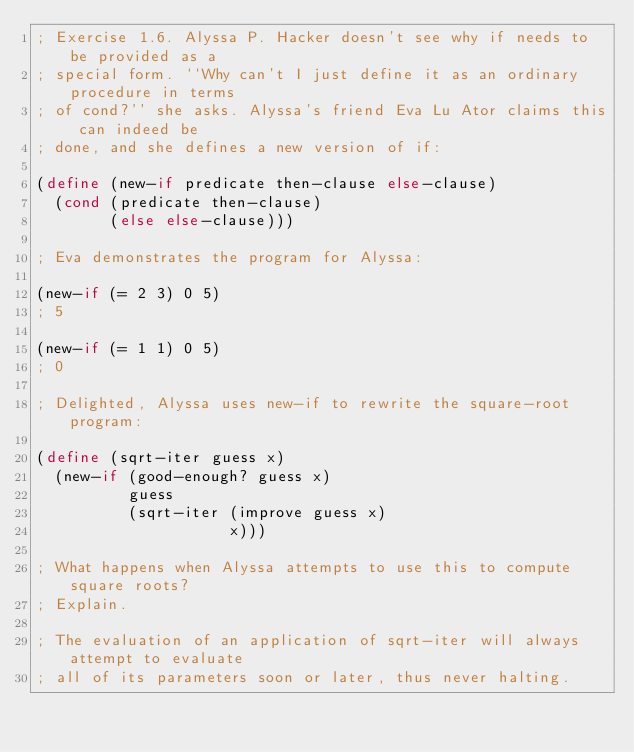<code> <loc_0><loc_0><loc_500><loc_500><_Scheme_>; Exercise 1.6. Alyssa P. Hacker doesn't see why if needs to be provided as a
; special form. ``Why can't I just define it as an ordinary procedure in terms
; of cond?'' she asks. Alyssa's friend Eva Lu Ator claims this can indeed be
; done, and she defines a new version of if:

(define (new-if predicate then-clause else-clause)
  (cond (predicate then-clause)
        (else else-clause)))

; Eva demonstrates the program for Alyssa:

(new-if (= 2 3) 0 5)
; 5

(new-if (= 1 1) 0 5)
; 0

; Delighted, Alyssa uses new-if to rewrite the square-root program:

(define (sqrt-iter guess x)
  (new-if (good-enough? guess x)
          guess
          (sqrt-iter (improve guess x)
                     x)))

; What happens when Alyssa attempts to use this to compute square roots?
; Explain.

; The evaluation of an application of sqrt-iter will always attempt to evaluate
; all of its parameters soon or later, thus never halting.
</code> 